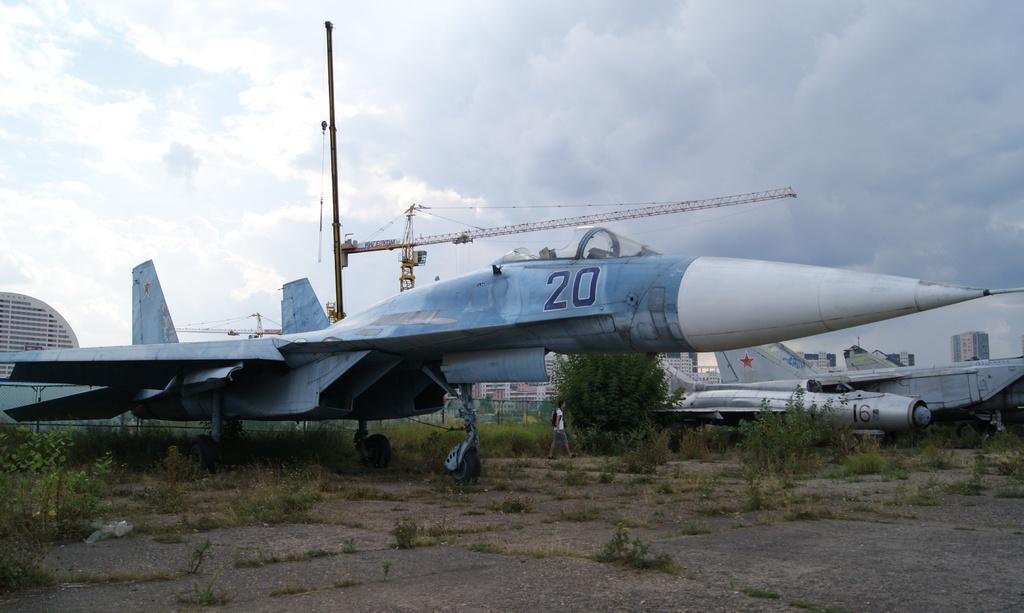What type of vehicles are in the image? There are fighter jets in the image. Can you describe the person's actions in the image? A person is walking beside a jet. What can be seen in the background of the image? There are trees, a fence, buildings, and cranes in the background of the image. What type of business is being conducted in the image? There is no indication of any business being conducted in the image; it primarily features fighter jets and a person walking beside one. Can you point out the door in the image? There is no door present in the image. 